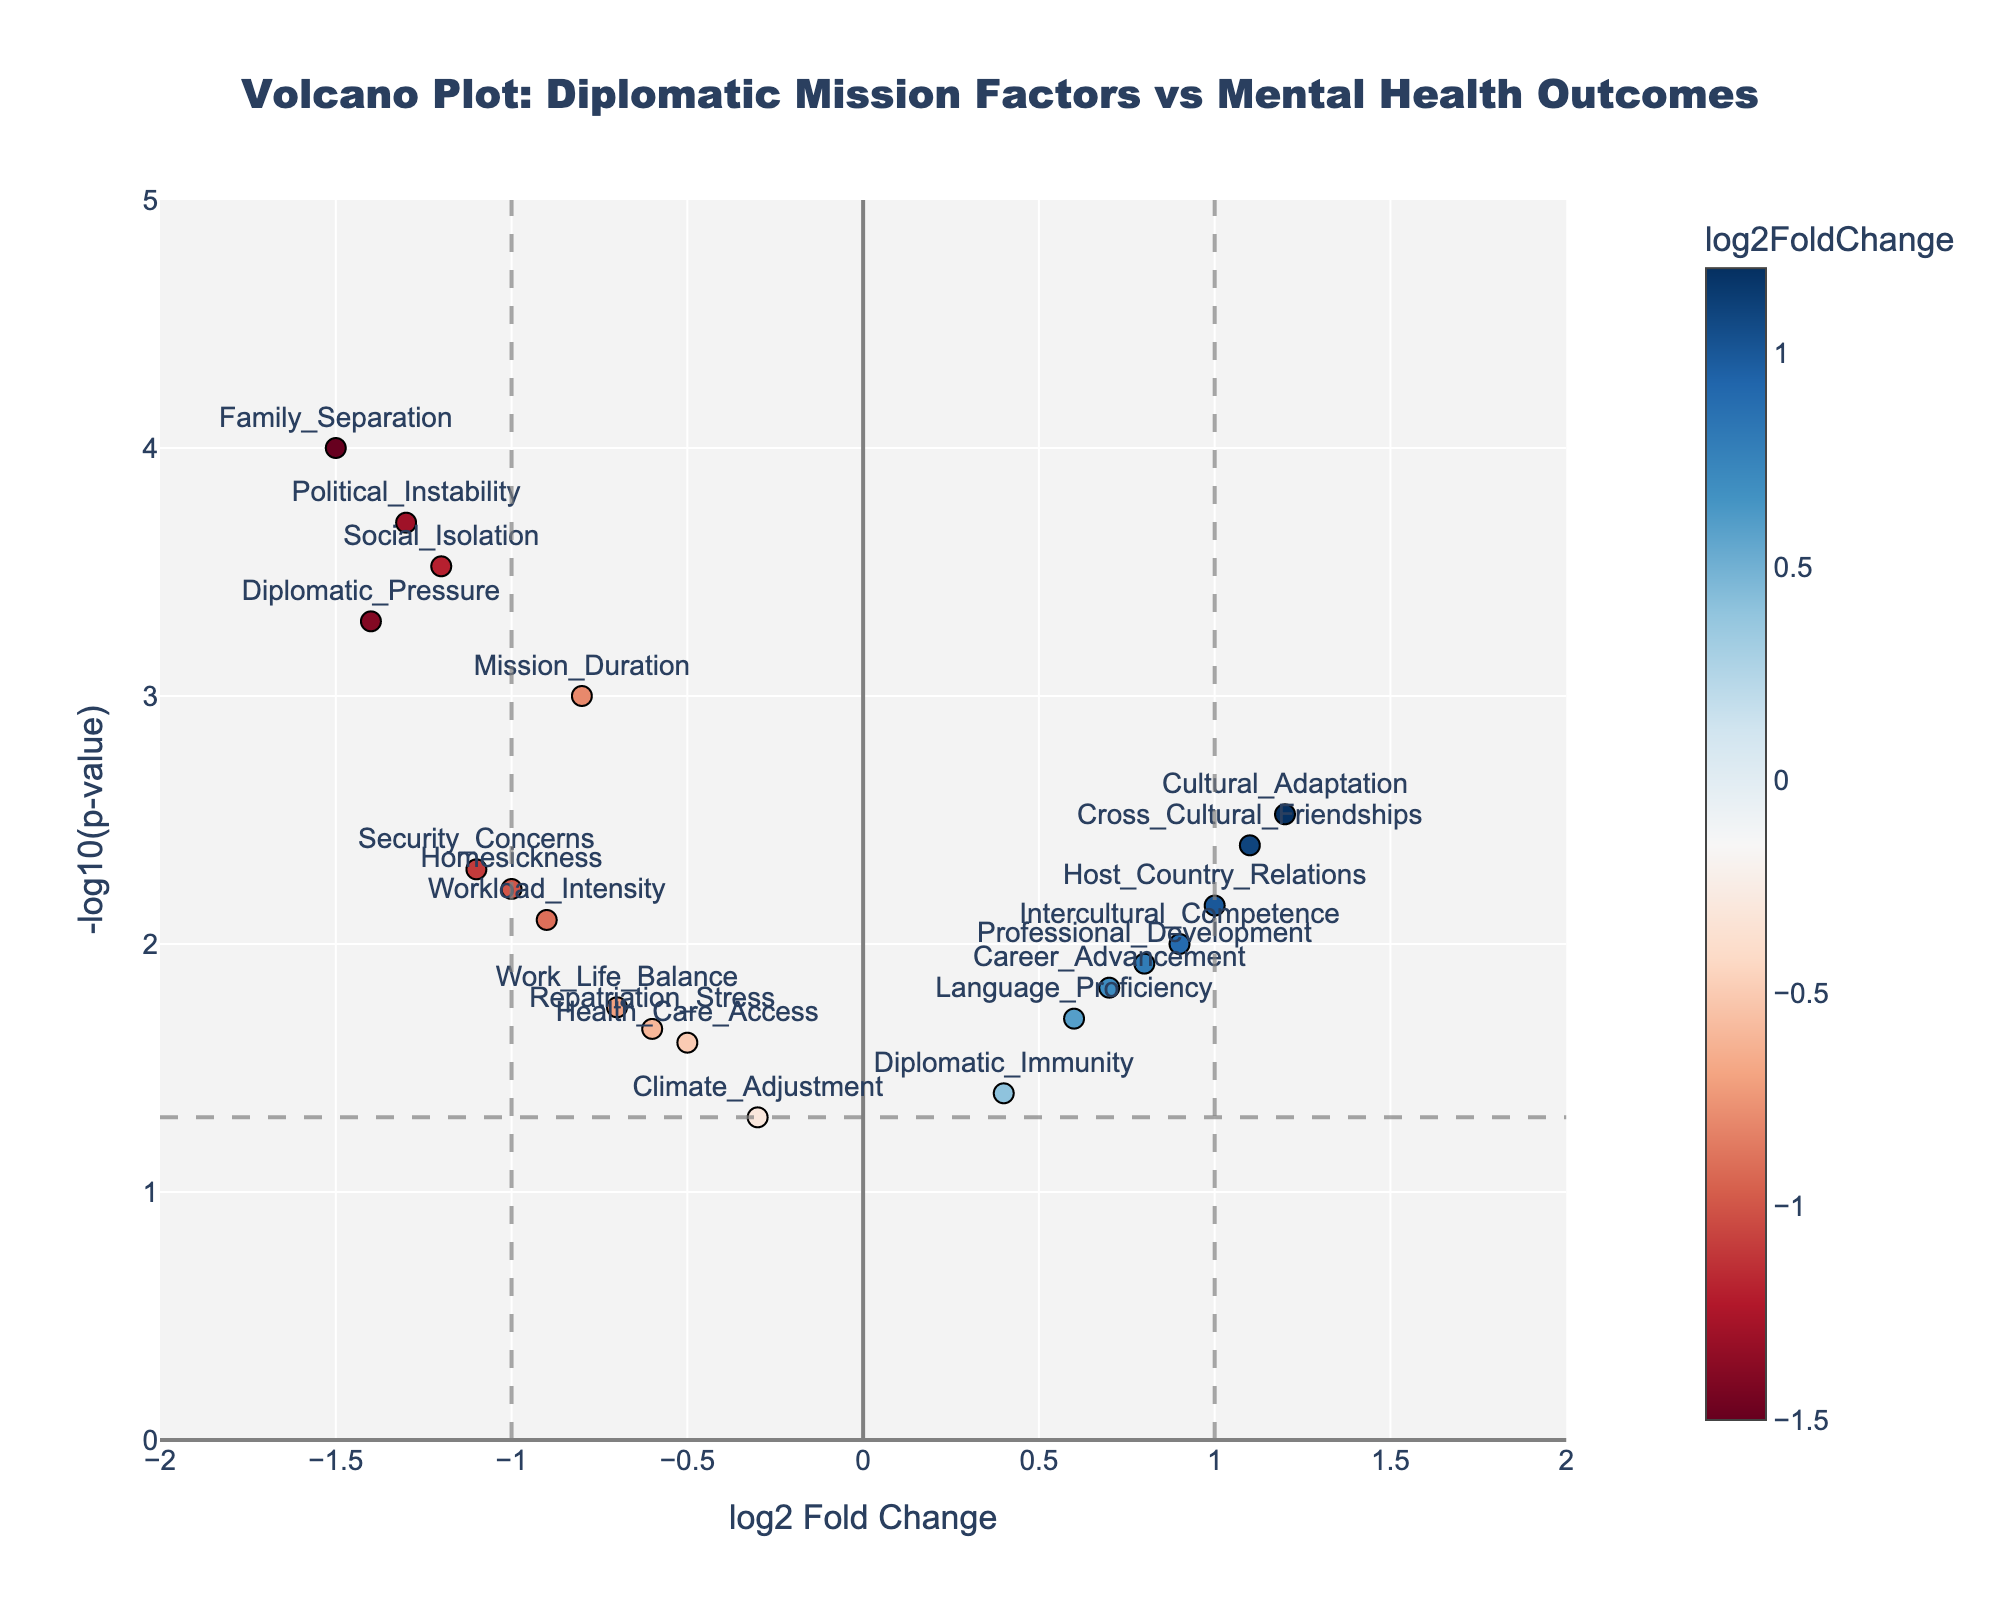What's the title of the plot? The title is usually found at the top of the plot. It provides an overview of what the plot is about. Here it is clearly stated.
Answer: "Volcano Plot: Diplomatic Mission Factors vs Mental Health Outcomes" What is the approximate range of the x-axis? The x-axis range can be determined by looking at the minimum and maximum values found on the x-axis markers.
Answer: Approximately -2 to 2 What is the vertical dashed line at x = 1 indicating? The vertical dashed line at x = 1 usually signifies an important threshold for log2FoldChange. In this case, it helps to visually separate positive significant changes from neutral/negative changes.
Answer: It indicates a threshold of log2FoldChange = 1 How many data points have a log2FoldChange greater than 1? To find the number of data points, count the markers with a log2FoldChange value greater than 1 on the x-axis.
Answer: 3 data points Which data point has the most negative log2FoldChange value? The most negative log2FoldChange value can be identified by looking for the leftmost marker (most negative x value).
Answer: Family_Separation Which factor is located at the highest -log10(p-value)? The highest -log10(p-value) is represented by the topmost marker on the plot.
Answer: Family_Separation What does the horizontal dashed line at y = -log10(0.05) represent? The horizontal dashed line typically represents a significance threshold. Here, y = -log10(0.05) is a common threshold for p-value significance.
Answer: It represents a significance threshold for p-value = 0.05 Are there more factors with positive or negative log2FoldChange values? Count the number of markers on each side of the zero value on the x-axis.
Answer: More factors have negative log2FoldChange values Which factor has the second lowest p-value? The p-value is represented by the height of the marker on the y-axis. To find the second lowest, look for the second highest point on the plot.
Answer: Political_Instability How many factors are both significant (below the p-value threshold) and have a negative log2FoldChange value? Count the markers below the horizontal dashed line and to the left of the zero value on the x-axis.
Answer: 7 factors 